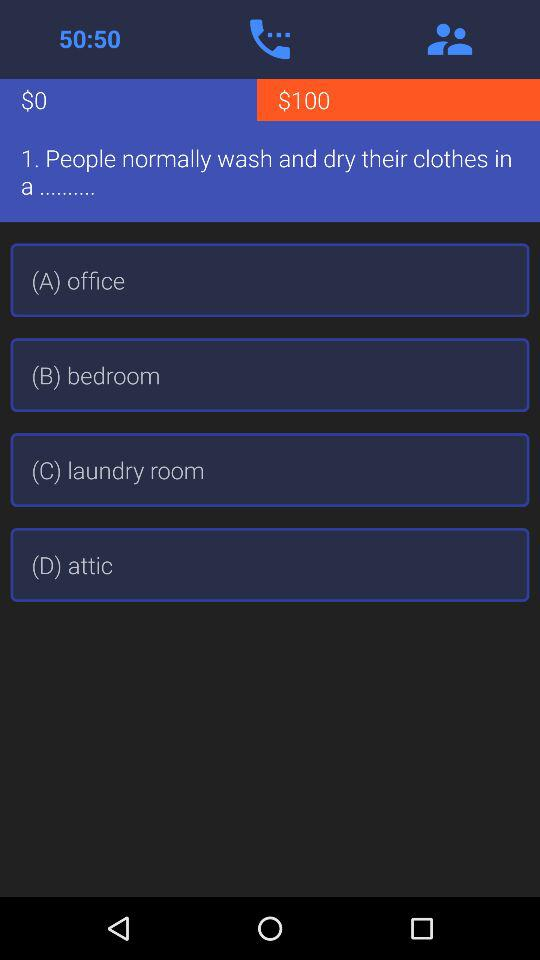What is the given time?
When the provided information is insufficient, respond with <no answer>. <no answer> 